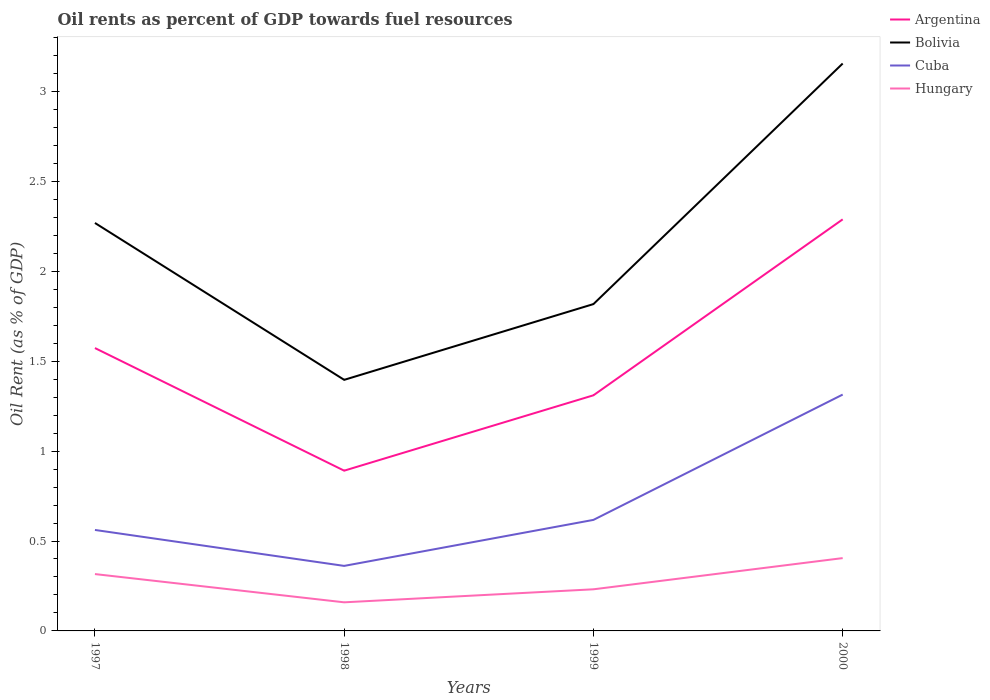How many different coloured lines are there?
Make the answer very short. 4. Is the number of lines equal to the number of legend labels?
Your response must be concise. Yes. Across all years, what is the maximum oil rent in Hungary?
Ensure brevity in your answer.  0.16. What is the total oil rent in Cuba in the graph?
Provide a short and direct response. -0.95. What is the difference between the highest and the second highest oil rent in Bolivia?
Give a very brief answer. 1.76. What is the difference between the highest and the lowest oil rent in Cuba?
Provide a succinct answer. 1. Is the oil rent in Argentina strictly greater than the oil rent in Bolivia over the years?
Your answer should be very brief. Yes. How many lines are there?
Ensure brevity in your answer.  4. How many years are there in the graph?
Your answer should be very brief. 4. What is the difference between two consecutive major ticks on the Y-axis?
Make the answer very short. 0.5. Are the values on the major ticks of Y-axis written in scientific E-notation?
Your response must be concise. No. Does the graph contain any zero values?
Keep it short and to the point. No. Does the graph contain grids?
Offer a very short reply. No. How are the legend labels stacked?
Keep it short and to the point. Vertical. What is the title of the graph?
Give a very brief answer. Oil rents as percent of GDP towards fuel resources. Does "El Salvador" appear as one of the legend labels in the graph?
Your answer should be compact. No. What is the label or title of the Y-axis?
Your response must be concise. Oil Rent (as % of GDP). What is the Oil Rent (as % of GDP) of Argentina in 1997?
Make the answer very short. 1.57. What is the Oil Rent (as % of GDP) of Bolivia in 1997?
Offer a terse response. 2.27. What is the Oil Rent (as % of GDP) in Cuba in 1997?
Your answer should be compact. 0.56. What is the Oil Rent (as % of GDP) in Hungary in 1997?
Make the answer very short. 0.32. What is the Oil Rent (as % of GDP) in Argentina in 1998?
Your answer should be compact. 0.89. What is the Oil Rent (as % of GDP) of Bolivia in 1998?
Ensure brevity in your answer.  1.4. What is the Oil Rent (as % of GDP) in Cuba in 1998?
Your answer should be very brief. 0.36. What is the Oil Rent (as % of GDP) in Hungary in 1998?
Provide a short and direct response. 0.16. What is the Oil Rent (as % of GDP) of Argentina in 1999?
Your response must be concise. 1.31. What is the Oil Rent (as % of GDP) of Bolivia in 1999?
Provide a short and direct response. 1.82. What is the Oil Rent (as % of GDP) in Cuba in 1999?
Keep it short and to the point. 0.62. What is the Oil Rent (as % of GDP) in Hungary in 1999?
Provide a succinct answer. 0.23. What is the Oil Rent (as % of GDP) of Argentina in 2000?
Provide a short and direct response. 2.29. What is the Oil Rent (as % of GDP) in Bolivia in 2000?
Offer a very short reply. 3.16. What is the Oil Rent (as % of GDP) of Cuba in 2000?
Ensure brevity in your answer.  1.31. What is the Oil Rent (as % of GDP) in Hungary in 2000?
Your answer should be compact. 0.4. Across all years, what is the maximum Oil Rent (as % of GDP) in Argentina?
Keep it short and to the point. 2.29. Across all years, what is the maximum Oil Rent (as % of GDP) in Bolivia?
Give a very brief answer. 3.16. Across all years, what is the maximum Oil Rent (as % of GDP) of Cuba?
Your response must be concise. 1.31. Across all years, what is the maximum Oil Rent (as % of GDP) in Hungary?
Your response must be concise. 0.4. Across all years, what is the minimum Oil Rent (as % of GDP) in Argentina?
Provide a short and direct response. 0.89. Across all years, what is the minimum Oil Rent (as % of GDP) of Bolivia?
Provide a short and direct response. 1.4. Across all years, what is the minimum Oil Rent (as % of GDP) in Cuba?
Make the answer very short. 0.36. Across all years, what is the minimum Oil Rent (as % of GDP) of Hungary?
Your response must be concise. 0.16. What is the total Oil Rent (as % of GDP) in Argentina in the graph?
Your response must be concise. 6.06. What is the total Oil Rent (as % of GDP) in Bolivia in the graph?
Your response must be concise. 8.64. What is the total Oil Rent (as % of GDP) in Cuba in the graph?
Keep it short and to the point. 2.85. What is the total Oil Rent (as % of GDP) of Hungary in the graph?
Your answer should be compact. 1.11. What is the difference between the Oil Rent (as % of GDP) in Argentina in 1997 and that in 1998?
Your answer should be compact. 0.68. What is the difference between the Oil Rent (as % of GDP) of Bolivia in 1997 and that in 1998?
Ensure brevity in your answer.  0.87. What is the difference between the Oil Rent (as % of GDP) of Cuba in 1997 and that in 1998?
Provide a succinct answer. 0.2. What is the difference between the Oil Rent (as % of GDP) of Hungary in 1997 and that in 1998?
Keep it short and to the point. 0.16. What is the difference between the Oil Rent (as % of GDP) in Argentina in 1997 and that in 1999?
Your answer should be very brief. 0.26. What is the difference between the Oil Rent (as % of GDP) of Bolivia in 1997 and that in 1999?
Offer a very short reply. 0.45. What is the difference between the Oil Rent (as % of GDP) in Cuba in 1997 and that in 1999?
Your answer should be very brief. -0.06. What is the difference between the Oil Rent (as % of GDP) of Hungary in 1997 and that in 1999?
Keep it short and to the point. 0.08. What is the difference between the Oil Rent (as % of GDP) of Argentina in 1997 and that in 2000?
Ensure brevity in your answer.  -0.72. What is the difference between the Oil Rent (as % of GDP) in Bolivia in 1997 and that in 2000?
Give a very brief answer. -0.89. What is the difference between the Oil Rent (as % of GDP) in Cuba in 1997 and that in 2000?
Your answer should be compact. -0.75. What is the difference between the Oil Rent (as % of GDP) of Hungary in 1997 and that in 2000?
Offer a terse response. -0.09. What is the difference between the Oil Rent (as % of GDP) of Argentina in 1998 and that in 1999?
Offer a very short reply. -0.42. What is the difference between the Oil Rent (as % of GDP) of Bolivia in 1998 and that in 1999?
Provide a succinct answer. -0.42. What is the difference between the Oil Rent (as % of GDP) of Cuba in 1998 and that in 1999?
Provide a short and direct response. -0.26. What is the difference between the Oil Rent (as % of GDP) in Hungary in 1998 and that in 1999?
Your answer should be compact. -0.07. What is the difference between the Oil Rent (as % of GDP) in Argentina in 1998 and that in 2000?
Your response must be concise. -1.4. What is the difference between the Oil Rent (as % of GDP) in Bolivia in 1998 and that in 2000?
Your answer should be compact. -1.76. What is the difference between the Oil Rent (as % of GDP) in Cuba in 1998 and that in 2000?
Provide a succinct answer. -0.95. What is the difference between the Oil Rent (as % of GDP) in Hungary in 1998 and that in 2000?
Your answer should be compact. -0.25. What is the difference between the Oil Rent (as % of GDP) in Argentina in 1999 and that in 2000?
Your response must be concise. -0.98. What is the difference between the Oil Rent (as % of GDP) of Bolivia in 1999 and that in 2000?
Provide a short and direct response. -1.34. What is the difference between the Oil Rent (as % of GDP) in Cuba in 1999 and that in 2000?
Provide a succinct answer. -0.7. What is the difference between the Oil Rent (as % of GDP) in Hungary in 1999 and that in 2000?
Keep it short and to the point. -0.17. What is the difference between the Oil Rent (as % of GDP) of Argentina in 1997 and the Oil Rent (as % of GDP) of Bolivia in 1998?
Your answer should be compact. 0.18. What is the difference between the Oil Rent (as % of GDP) of Argentina in 1997 and the Oil Rent (as % of GDP) of Cuba in 1998?
Provide a short and direct response. 1.21. What is the difference between the Oil Rent (as % of GDP) of Argentina in 1997 and the Oil Rent (as % of GDP) of Hungary in 1998?
Offer a very short reply. 1.41. What is the difference between the Oil Rent (as % of GDP) in Bolivia in 1997 and the Oil Rent (as % of GDP) in Cuba in 1998?
Offer a terse response. 1.91. What is the difference between the Oil Rent (as % of GDP) in Bolivia in 1997 and the Oil Rent (as % of GDP) in Hungary in 1998?
Ensure brevity in your answer.  2.11. What is the difference between the Oil Rent (as % of GDP) in Cuba in 1997 and the Oil Rent (as % of GDP) in Hungary in 1998?
Offer a very short reply. 0.4. What is the difference between the Oil Rent (as % of GDP) of Argentina in 1997 and the Oil Rent (as % of GDP) of Bolivia in 1999?
Your answer should be very brief. -0.24. What is the difference between the Oil Rent (as % of GDP) of Argentina in 1997 and the Oil Rent (as % of GDP) of Cuba in 1999?
Provide a short and direct response. 0.96. What is the difference between the Oil Rent (as % of GDP) in Argentina in 1997 and the Oil Rent (as % of GDP) in Hungary in 1999?
Keep it short and to the point. 1.34. What is the difference between the Oil Rent (as % of GDP) in Bolivia in 1997 and the Oil Rent (as % of GDP) in Cuba in 1999?
Make the answer very short. 1.65. What is the difference between the Oil Rent (as % of GDP) of Bolivia in 1997 and the Oil Rent (as % of GDP) of Hungary in 1999?
Ensure brevity in your answer.  2.04. What is the difference between the Oil Rent (as % of GDP) of Cuba in 1997 and the Oil Rent (as % of GDP) of Hungary in 1999?
Make the answer very short. 0.33. What is the difference between the Oil Rent (as % of GDP) in Argentina in 1997 and the Oil Rent (as % of GDP) in Bolivia in 2000?
Your response must be concise. -1.58. What is the difference between the Oil Rent (as % of GDP) of Argentina in 1997 and the Oil Rent (as % of GDP) of Cuba in 2000?
Give a very brief answer. 0.26. What is the difference between the Oil Rent (as % of GDP) in Argentina in 1997 and the Oil Rent (as % of GDP) in Hungary in 2000?
Ensure brevity in your answer.  1.17. What is the difference between the Oil Rent (as % of GDP) of Bolivia in 1997 and the Oil Rent (as % of GDP) of Cuba in 2000?
Ensure brevity in your answer.  0.95. What is the difference between the Oil Rent (as % of GDP) of Bolivia in 1997 and the Oil Rent (as % of GDP) of Hungary in 2000?
Your answer should be very brief. 1.86. What is the difference between the Oil Rent (as % of GDP) in Cuba in 1997 and the Oil Rent (as % of GDP) in Hungary in 2000?
Offer a very short reply. 0.16. What is the difference between the Oil Rent (as % of GDP) of Argentina in 1998 and the Oil Rent (as % of GDP) of Bolivia in 1999?
Your answer should be very brief. -0.93. What is the difference between the Oil Rent (as % of GDP) of Argentina in 1998 and the Oil Rent (as % of GDP) of Cuba in 1999?
Your answer should be compact. 0.27. What is the difference between the Oil Rent (as % of GDP) of Argentina in 1998 and the Oil Rent (as % of GDP) of Hungary in 1999?
Your answer should be compact. 0.66. What is the difference between the Oil Rent (as % of GDP) in Bolivia in 1998 and the Oil Rent (as % of GDP) in Cuba in 1999?
Offer a terse response. 0.78. What is the difference between the Oil Rent (as % of GDP) of Bolivia in 1998 and the Oil Rent (as % of GDP) of Hungary in 1999?
Offer a terse response. 1.16. What is the difference between the Oil Rent (as % of GDP) in Cuba in 1998 and the Oil Rent (as % of GDP) in Hungary in 1999?
Your response must be concise. 0.13. What is the difference between the Oil Rent (as % of GDP) of Argentina in 1998 and the Oil Rent (as % of GDP) of Bolivia in 2000?
Provide a short and direct response. -2.26. What is the difference between the Oil Rent (as % of GDP) in Argentina in 1998 and the Oil Rent (as % of GDP) in Cuba in 2000?
Make the answer very short. -0.42. What is the difference between the Oil Rent (as % of GDP) in Argentina in 1998 and the Oil Rent (as % of GDP) in Hungary in 2000?
Offer a very short reply. 0.49. What is the difference between the Oil Rent (as % of GDP) of Bolivia in 1998 and the Oil Rent (as % of GDP) of Cuba in 2000?
Make the answer very short. 0.08. What is the difference between the Oil Rent (as % of GDP) in Cuba in 1998 and the Oil Rent (as % of GDP) in Hungary in 2000?
Provide a succinct answer. -0.04. What is the difference between the Oil Rent (as % of GDP) in Argentina in 1999 and the Oil Rent (as % of GDP) in Bolivia in 2000?
Your answer should be compact. -1.84. What is the difference between the Oil Rent (as % of GDP) in Argentina in 1999 and the Oil Rent (as % of GDP) in Cuba in 2000?
Your answer should be very brief. -0. What is the difference between the Oil Rent (as % of GDP) of Argentina in 1999 and the Oil Rent (as % of GDP) of Hungary in 2000?
Keep it short and to the point. 0.91. What is the difference between the Oil Rent (as % of GDP) in Bolivia in 1999 and the Oil Rent (as % of GDP) in Cuba in 2000?
Provide a succinct answer. 0.5. What is the difference between the Oil Rent (as % of GDP) of Bolivia in 1999 and the Oil Rent (as % of GDP) of Hungary in 2000?
Your response must be concise. 1.41. What is the difference between the Oil Rent (as % of GDP) of Cuba in 1999 and the Oil Rent (as % of GDP) of Hungary in 2000?
Ensure brevity in your answer.  0.21. What is the average Oil Rent (as % of GDP) of Argentina per year?
Keep it short and to the point. 1.52. What is the average Oil Rent (as % of GDP) of Bolivia per year?
Offer a very short reply. 2.16. What is the average Oil Rent (as % of GDP) in Cuba per year?
Make the answer very short. 0.71. What is the average Oil Rent (as % of GDP) in Hungary per year?
Ensure brevity in your answer.  0.28. In the year 1997, what is the difference between the Oil Rent (as % of GDP) of Argentina and Oil Rent (as % of GDP) of Bolivia?
Offer a very short reply. -0.7. In the year 1997, what is the difference between the Oil Rent (as % of GDP) in Argentina and Oil Rent (as % of GDP) in Cuba?
Give a very brief answer. 1.01. In the year 1997, what is the difference between the Oil Rent (as % of GDP) of Argentina and Oil Rent (as % of GDP) of Hungary?
Give a very brief answer. 1.26. In the year 1997, what is the difference between the Oil Rent (as % of GDP) of Bolivia and Oil Rent (as % of GDP) of Cuba?
Your answer should be very brief. 1.71. In the year 1997, what is the difference between the Oil Rent (as % of GDP) in Bolivia and Oil Rent (as % of GDP) in Hungary?
Make the answer very short. 1.95. In the year 1997, what is the difference between the Oil Rent (as % of GDP) of Cuba and Oil Rent (as % of GDP) of Hungary?
Your response must be concise. 0.25. In the year 1998, what is the difference between the Oil Rent (as % of GDP) in Argentina and Oil Rent (as % of GDP) in Bolivia?
Ensure brevity in your answer.  -0.51. In the year 1998, what is the difference between the Oil Rent (as % of GDP) in Argentina and Oil Rent (as % of GDP) in Cuba?
Offer a terse response. 0.53. In the year 1998, what is the difference between the Oil Rent (as % of GDP) of Argentina and Oil Rent (as % of GDP) of Hungary?
Your answer should be compact. 0.73. In the year 1998, what is the difference between the Oil Rent (as % of GDP) of Bolivia and Oil Rent (as % of GDP) of Cuba?
Give a very brief answer. 1.03. In the year 1998, what is the difference between the Oil Rent (as % of GDP) of Bolivia and Oil Rent (as % of GDP) of Hungary?
Make the answer very short. 1.24. In the year 1998, what is the difference between the Oil Rent (as % of GDP) in Cuba and Oil Rent (as % of GDP) in Hungary?
Make the answer very short. 0.2. In the year 1999, what is the difference between the Oil Rent (as % of GDP) of Argentina and Oil Rent (as % of GDP) of Bolivia?
Your answer should be very brief. -0.51. In the year 1999, what is the difference between the Oil Rent (as % of GDP) of Argentina and Oil Rent (as % of GDP) of Cuba?
Keep it short and to the point. 0.69. In the year 1999, what is the difference between the Oil Rent (as % of GDP) in Argentina and Oil Rent (as % of GDP) in Hungary?
Offer a terse response. 1.08. In the year 1999, what is the difference between the Oil Rent (as % of GDP) in Bolivia and Oil Rent (as % of GDP) in Cuba?
Provide a succinct answer. 1.2. In the year 1999, what is the difference between the Oil Rent (as % of GDP) in Bolivia and Oil Rent (as % of GDP) in Hungary?
Make the answer very short. 1.59. In the year 1999, what is the difference between the Oil Rent (as % of GDP) in Cuba and Oil Rent (as % of GDP) in Hungary?
Your answer should be very brief. 0.39. In the year 2000, what is the difference between the Oil Rent (as % of GDP) in Argentina and Oil Rent (as % of GDP) in Bolivia?
Your answer should be compact. -0.87. In the year 2000, what is the difference between the Oil Rent (as % of GDP) of Argentina and Oil Rent (as % of GDP) of Cuba?
Offer a very short reply. 0.97. In the year 2000, what is the difference between the Oil Rent (as % of GDP) of Argentina and Oil Rent (as % of GDP) of Hungary?
Give a very brief answer. 1.88. In the year 2000, what is the difference between the Oil Rent (as % of GDP) of Bolivia and Oil Rent (as % of GDP) of Cuba?
Provide a short and direct response. 1.84. In the year 2000, what is the difference between the Oil Rent (as % of GDP) of Bolivia and Oil Rent (as % of GDP) of Hungary?
Provide a succinct answer. 2.75. In the year 2000, what is the difference between the Oil Rent (as % of GDP) in Cuba and Oil Rent (as % of GDP) in Hungary?
Your answer should be compact. 0.91. What is the ratio of the Oil Rent (as % of GDP) in Argentina in 1997 to that in 1998?
Your response must be concise. 1.77. What is the ratio of the Oil Rent (as % of GDP) of Bolivia in 1997 to that in 1998?
Your answer should be very brief. 1.62. What is the ratio of the Oil Rent (as % of GDP) in Cuba in 1997 to that in 1998?
Offer a terse response. 1.55. What is the ratio of the Oil Rent (as % of GDP) of Hungary in 1997 to that in 1998?
Provide a succinct answer. 1.99. What is the ratio of the Oil Rent (as % of GDP) in Argentina in 1997 to that in 1999?
Offer a terse response. 1.2. What is the ratio of the Oil Rent (as % of GDP) of Bolivia in 1997 to that in 1999?
Provide a short and direct response. 1.25. What is the ratio of the Oil Rent (as % of GDP) in Cuba in 1997 to that in 1999?
Provide a short and direct response. 0.91. What is the ratio of the Oil Rent (as % of GDP) of Hungary in 1997 to that in 1999?
Your answer should be very brief. 1.37. What is the ratio of the Oil Rent (as % of GDP) in Argentina in 1997 to that in 2000?
Your answer should be compact. 0.69. What is the ratio of the Oil Rent (as % of GDP) in Bolivia in 1997 to that in 2000?
Offer a very short reply. 0.72. What is the ratio of the Oil Rent (as % of GDP) in Cuba in 1997 to that in 2000?
Provide a short and direct response. 0.43. What is the ratio of the Oil Rent (as % of GDP) of Hungary in 1997 to that in 2000?
Your answer should be very brief. 0.78. What is the ratio of the Oil Rent (as % of GDP) of Argentina in 1998 to that in 1999?
Offer a terse response. 0.68. What is the ratio of the Oil Rent (as % of GDP) of Bolivia in 1998 to that in 1999?
Your answer should be compact. 0.77. What is the ratio of the Oil Rent (as % of GDP) of Cuba in 1998 to that in 1999?
Provide a succinct answer. 0.59. What is the ratio of the Oil Rent (as % of GDP) of Hungary in 1998 to that in 1999?
Your answer should be very brief. 0.69. What is the ratio of the Oil Rent (as % of GDP) in Argentina in 1998 to that in 2000?
Keep it short and to the point. 0.39. What is the ratio of the Oil Rent (as % of GDP) of Bolivia in 1998 to that in 2000?
Ensure brevity in your answer.  0.44. What is the ratio of the Oil Rent (as % of GDP) in Cuba in 1998 to that in 2000?
Give a very brief answer. 0.28. What is the ratio of the Oil Rent (as % of GDP) of Hungary in 1998 to that in 2000?
Give a very brief answer. 0.39. What is the ratio of the Oil Rent (as % of GDP) of Argentina in 1999 to that in 2000?
Provide a succinct answer. 0.57. What is the ratio of the Oil Rent (as % of GDP) in Bolivia in 1999 to that in 2000?
Provide a succinct answer. 0.58. What is the ratio of the Oil Rent (as % of GDP) in Cuba in 1999 to that in 2000?
Make the answer very short. 0.47. What is the ratio of the Oil Rent (as % of GDP) of Hungary in 1999 to that in 2000?
Ensure brevity in your answer.  0.57. What is the difference between the highest and the second highest Oil Rent (as % of GDP) of Argentina?
Offer a very short reply. 0.72. What is the difference between the highest and the second highest Oil Rent (as % of GDP) of Bolivia?
Keep it short and to the point. 0.89. What is the difference between the highest and the second highest Oil Rent (as % of GDP) of Cuba?
Offer a terse response. 0.7. What is the difference between the highest and the second highest Oil Rent (as % of GDP) in Hungary?
Offer a terse response. 0.09. What is the difference between the highest and the lowest Oil Rent (as % of GDP) in Argentina?
Offer a terse response. 1.4. What is the difference between the highest and the lowest Oil Rent (as % of GDP) in Bolivia?
Provide a short and direct response. 1.76. What is the difference between the highest and the lowest Oil Rent (as % of GDP) in Cuba?
Your answer should be very brief. 0.95. What is the difference between the highest and the lowest Oil Rent (as % of GDP) in Hungary?
Offer a very short reply. 0.25. 